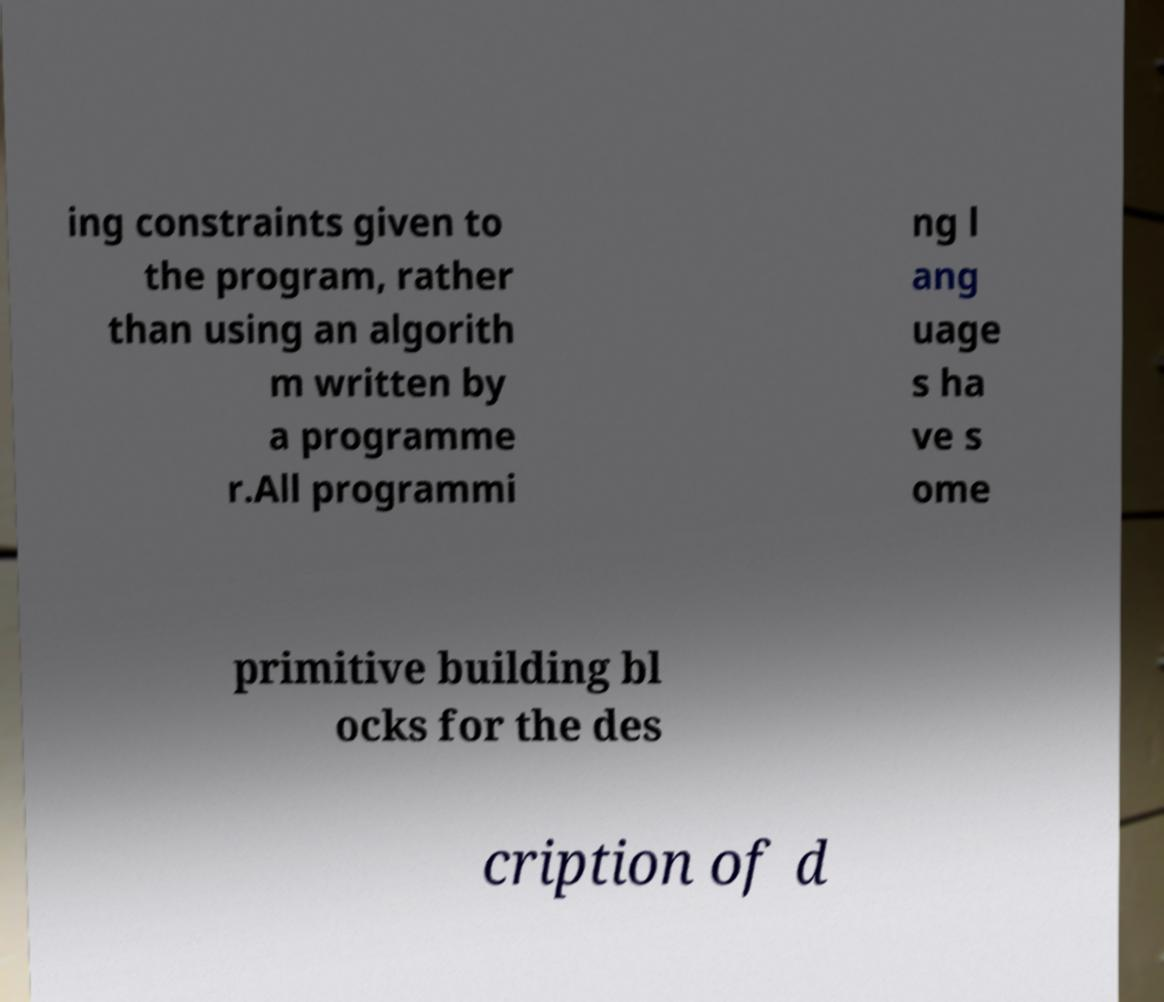Can you read and provide the text displayed in the image?This photo seems to have some interesting text. Can you extract and type it out for me? ing constraints given to the program, rather than using an algorith m written by a programme r.All programmi ng l ang uage s ha ve s ome primitive building bl ocks for the des cription of d 